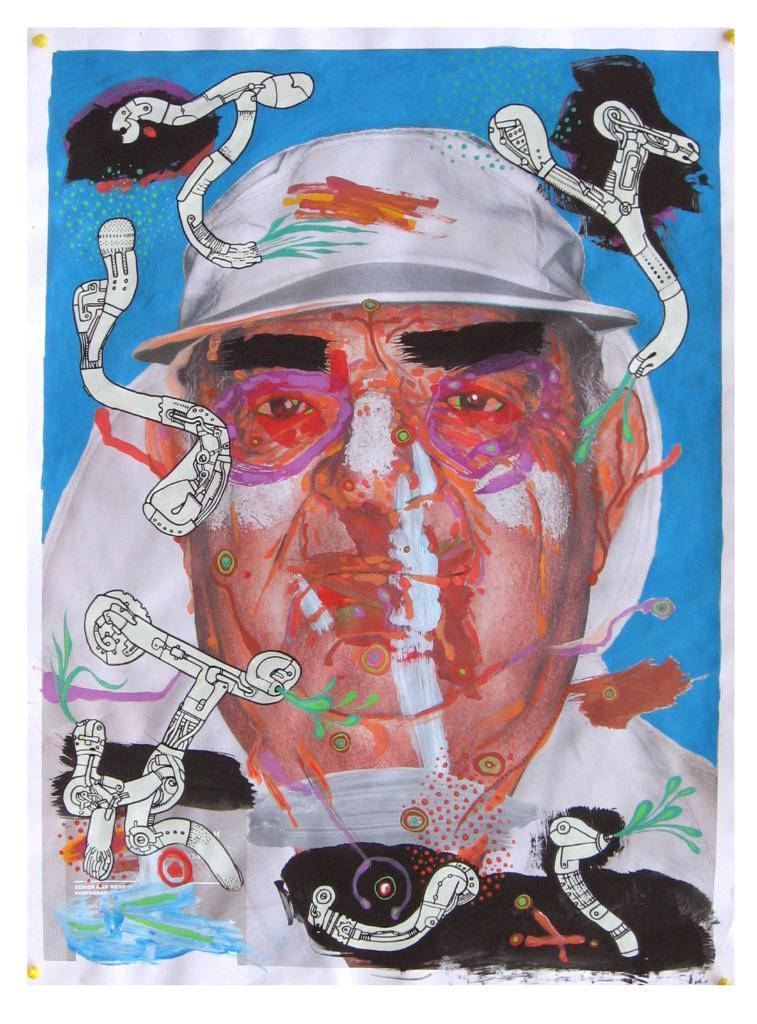How would you summarize this image in a sentence or two? In this image I can see depiction picture where I can see a man and few white color things. I can also see blue color in the background. 